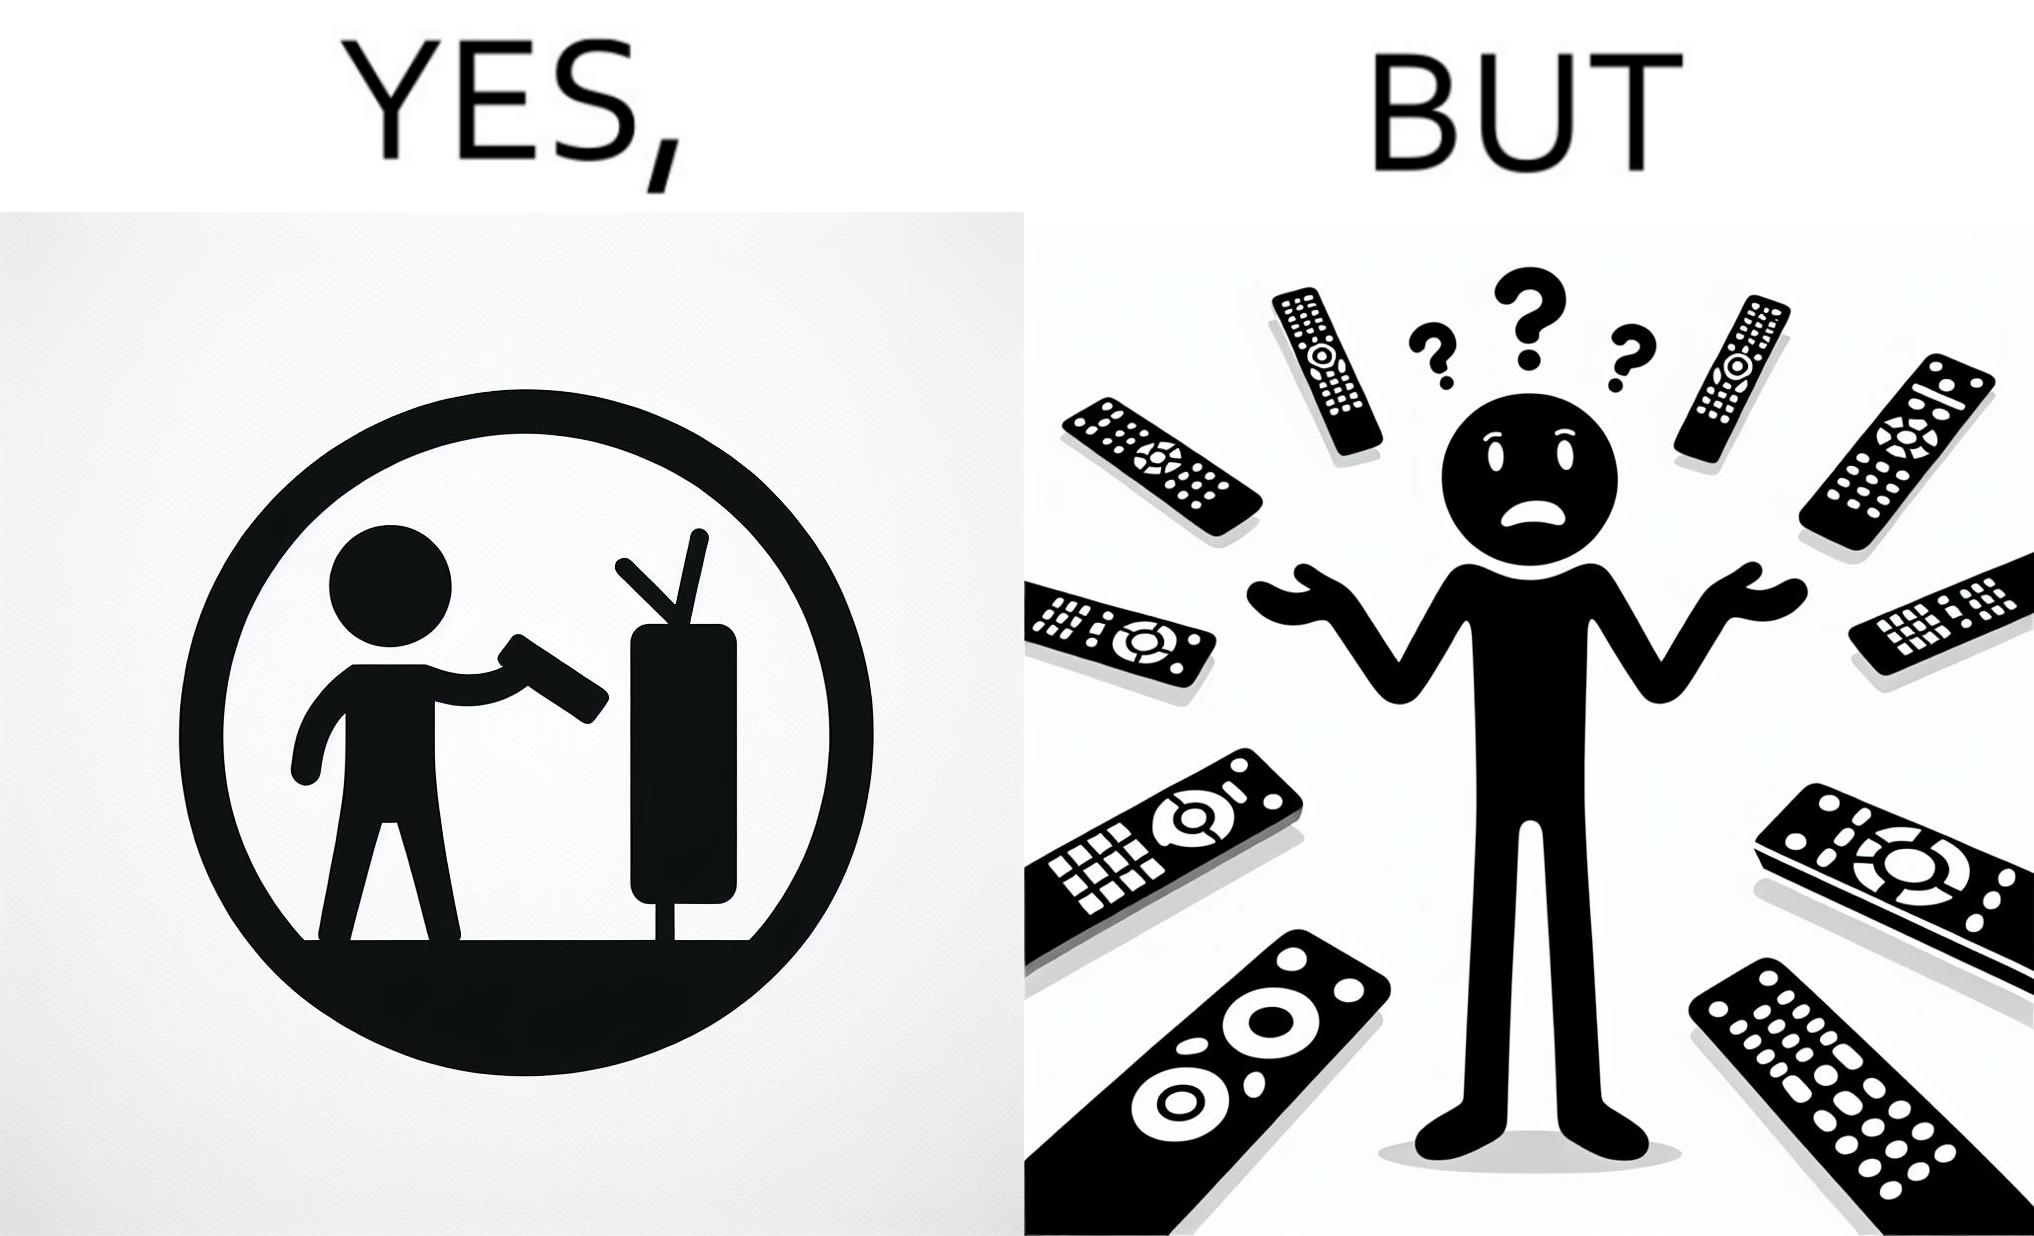Does this image contain satire or humor? Yes, this image is satirical. 